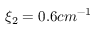Convert formula to latex. <formula><loc_0><loc_0><loc_500><loc_500>\xi _ { 2 } = 0 . 6 c m ^ { - 1 }</formula> 